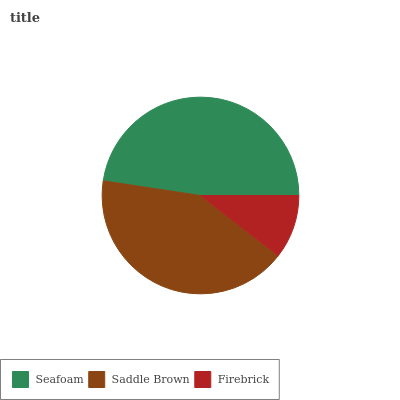Is Firebrick the minimum?
Answer yes or no. Yes. Is Seafoam the maximum?
Answer yes or no. Yes. Is Saddle Brown the minimum?
Answer yes or no. No. Is Saddle Brown the maximum?
Answer yes or no. No. Is Seafoam greater than Saddle Brown?
Answer yes or no. Yes. Is Saddle Brown less than Seafoam?
Answer yes or no. Yes. Is Saddle Brown greater than Seafoam?
Answer yes or no. No. Is Seafoam less than Saddle Brown?
Answer yes or no. No. Is Saddle Brown the high median?
Answer yes or no. Yes. Is Saddle Brown the low median?
Answer yes or no. Yes. Is Seafoam the high median?
Answer yes or no. No. Is Seafoam the low median?
Answer yes or no. No. 